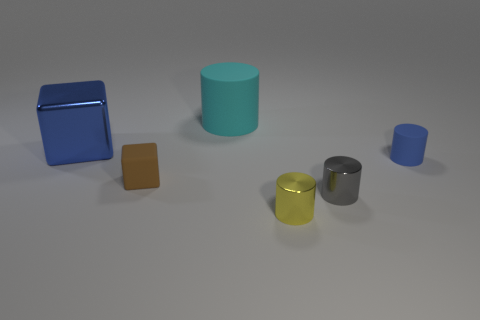Add 2 large purple matte balls. How many objects exist? 8 Subtract all small cylinders. How many cylinders are left? 1 Subtract all blocks. How many objects are left? 4 Add 4 blue rubber objects. How many blue rubber objects exist? 5 Subtract all yellow cylinders. How many cylinders are left? 3 Subtract 0 brown cylinders. How many objects are left? 6 Subtract 1 cylinders. How many cylinders are left? 3 Subtract all cyan cubes. Subtract all blue spheres. How many cubes are left? 2 Subtract all big cubes. Subtract all large blue metal cubes. How many objects are left? 4 Add 3 tiny yellow cylinders. How many tiny yellow cylinders are left? 4 